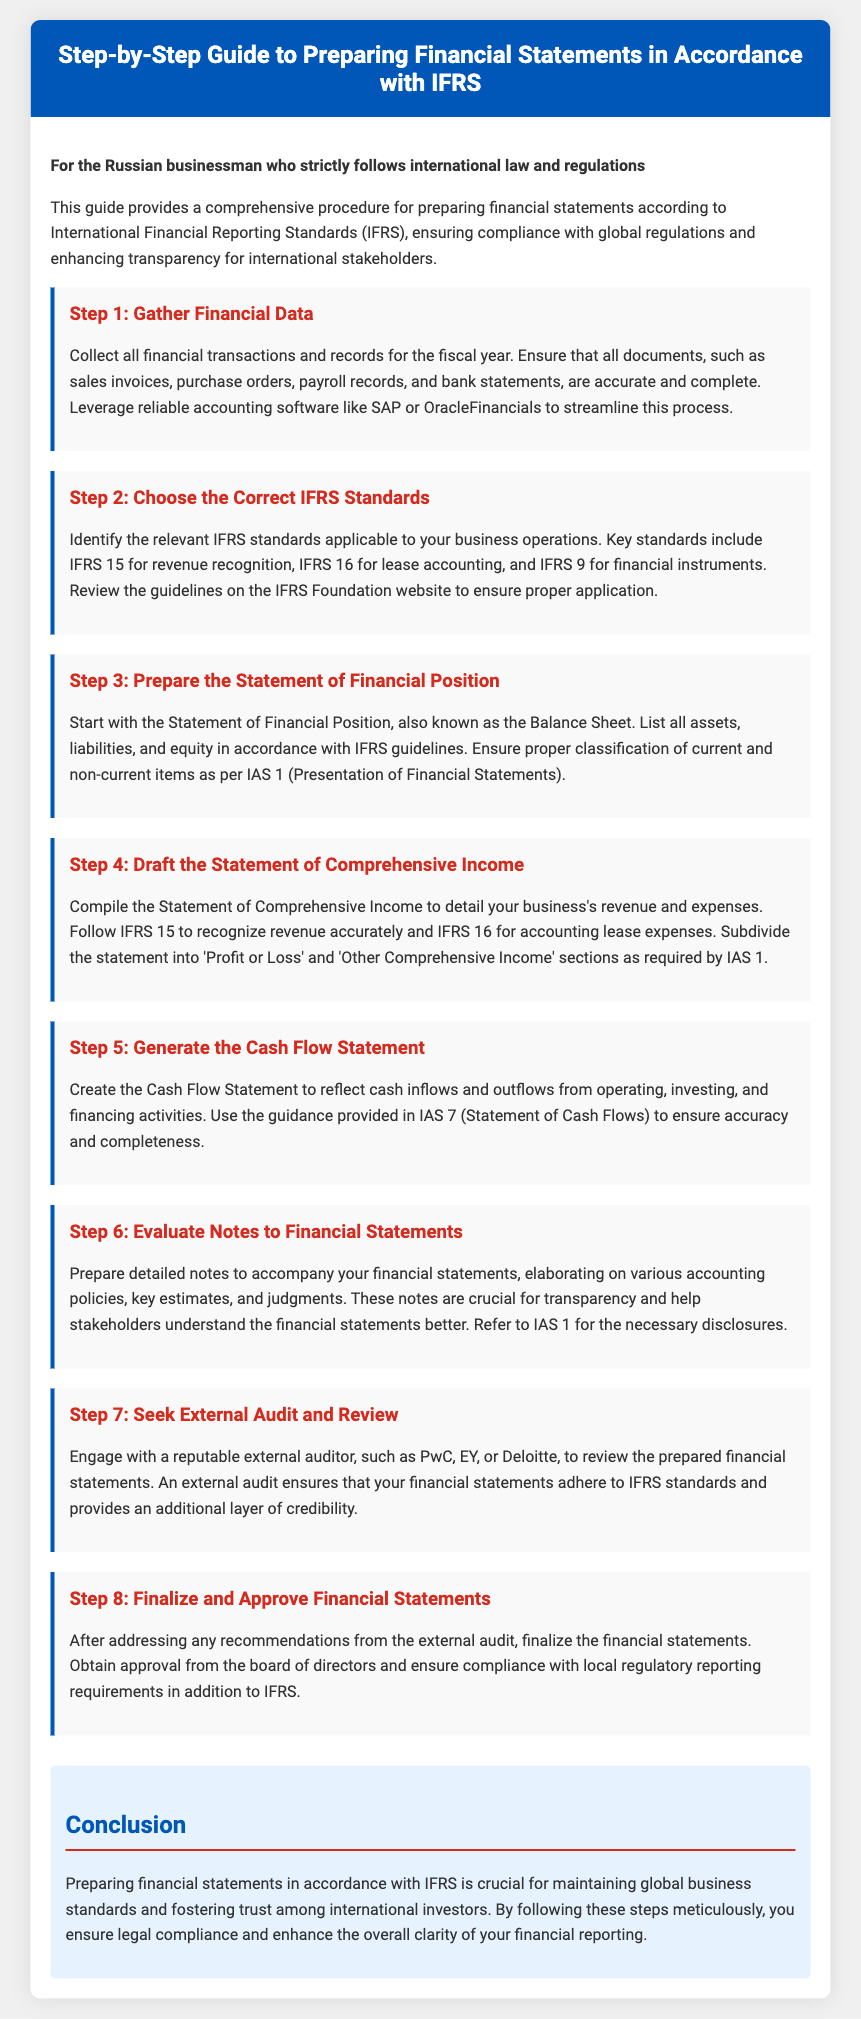what is the title of the document? The title clearly presented in the header of the document is about preparing financial statements in accordance with IFRS.
Answer: Step-by-Step Guide to Preparing Financial Statements in Accordance with IFRS how many steps are included in the guide? The document outlines a systematic procedure for financial statement preparation, detailing eight distinct steps.
Answer: 8 what is the first step in the guide? The guide lays out the procedures starting with financial data collection, as indicated in the first step.
Answer: Gather Financial Data which IFRS standard is related to revenue recognition? The document specifies the relevant IFRS standard applicable for recognizing revenue in the second step.
Answer: IFRS 15 who should perform the external audit? The document recommends engaging a reputable external auditor, providing examples of firms known for such services.
Answer: PwC, EY, or Deloitte what section is included in the Statement of Comprehensive Income? The guide indicates that this statement should include specific sections defined under the relevant IFRS guidelines.
Answer: Profit or Loss and Other Comprehensive Income what is the purpose of the notes to financial statements? The document highlights the importance of detailed notes in providing clarity and understanding for stakeholders.
Answer: Transparency which IAS provides disclosure requirements? The guide points to a specific IAS that outlines necessary disclosures related to financial statements.
Answer: IAS 1 